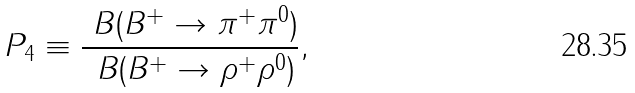<formula> <loc_0><loc_0><loc_500><loc_500>P _ { 4 } \equiv \frac { \ B ( { B ^ { + } } \to \pi ^ { + } \pi ^ { 0 } ) } { \ B ( B ^ { + } \to \rho ^ { + } \rho ^ { 0 } ) } ,</formula> 